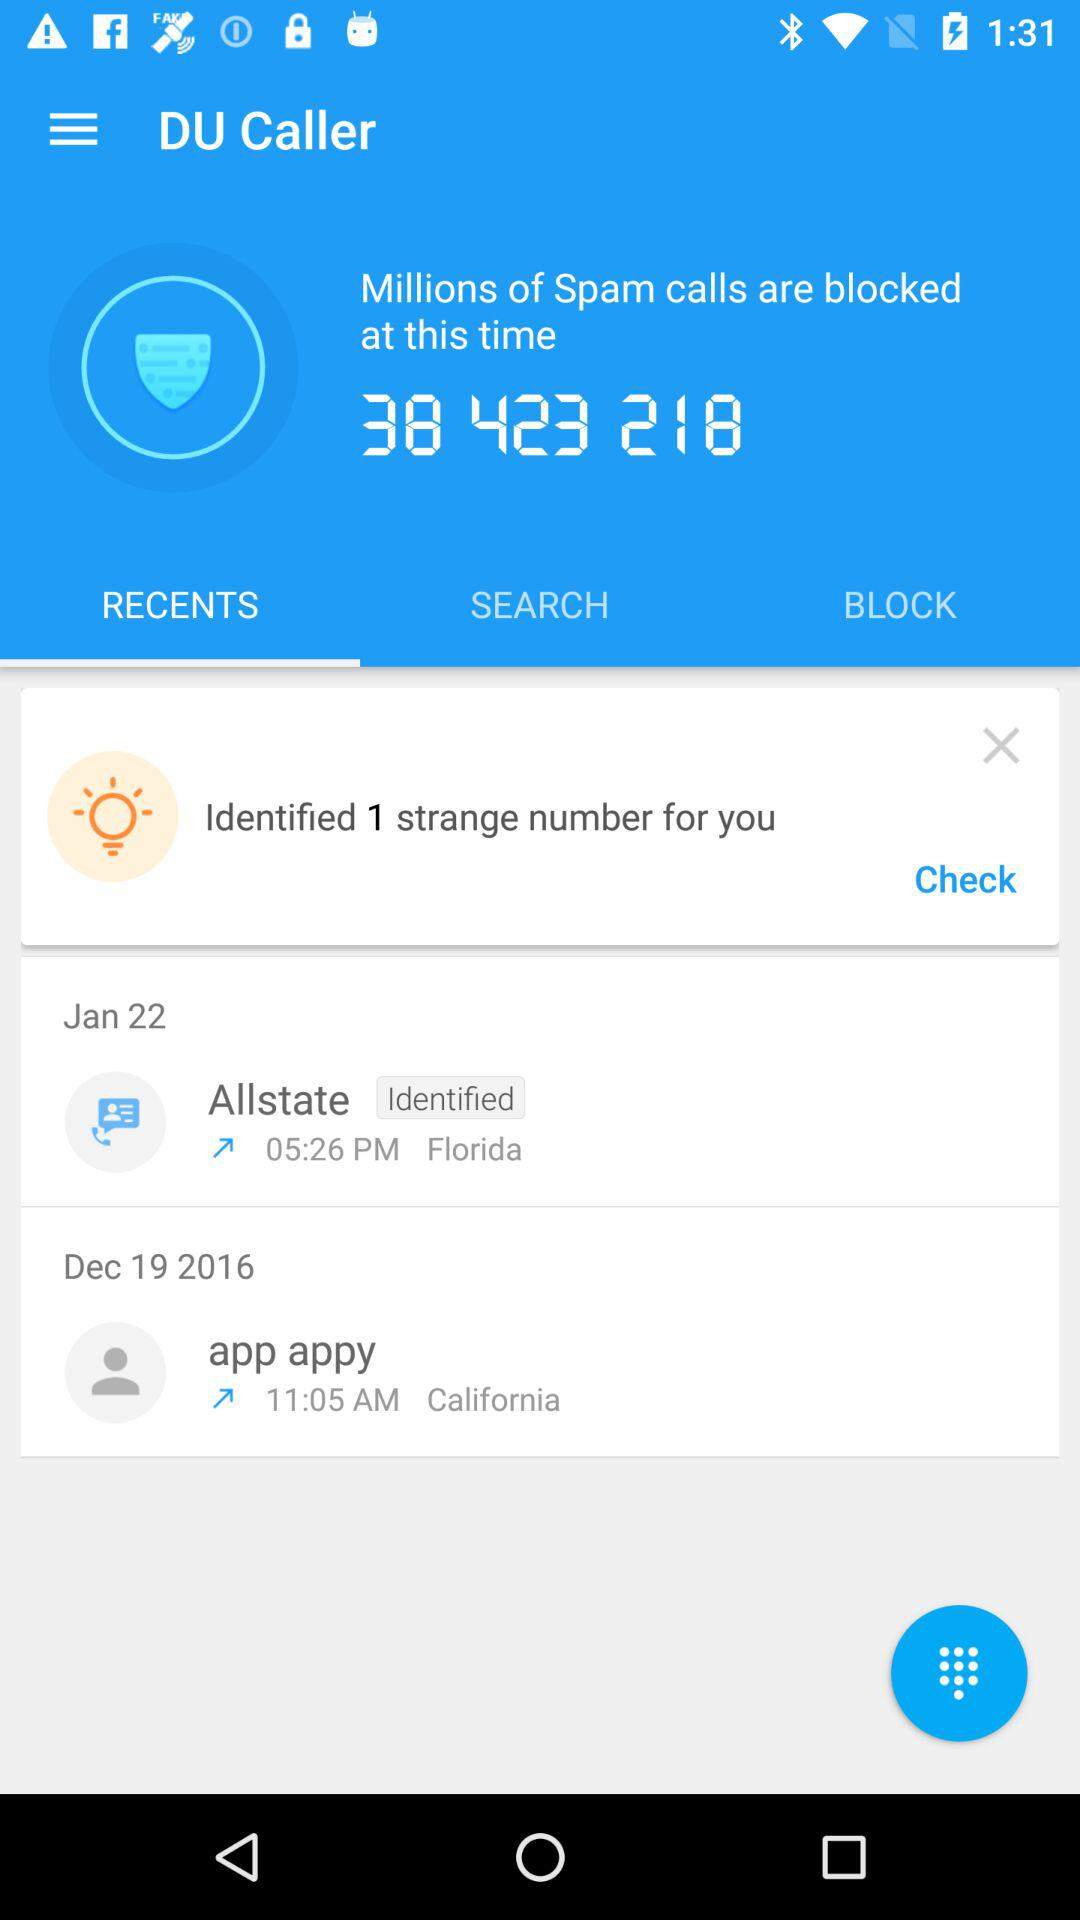How many strange numbers have been identified? There is 1 strange number identified. 